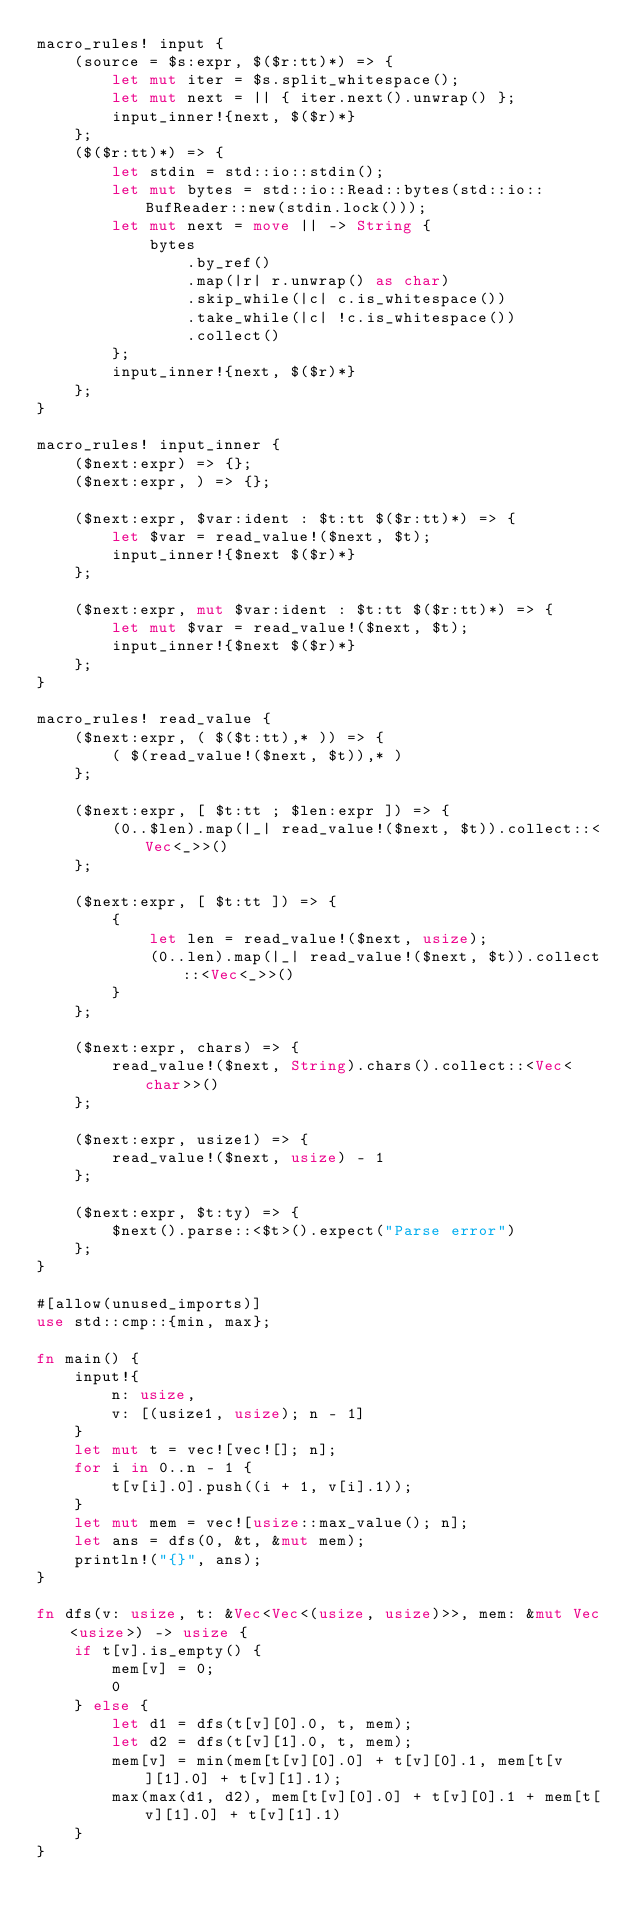<code> <loc_0><loc_0><loc_500><loc_500><_Rust_>macro_rules! input {
    (source = $s:expr, $($r:tt)*) => {
        let mut iter = $s.split_whitespace();
        let mut next = || { iter.next().unwrap() };
        input_inner!{next, $($r)*}
    };
    ($($r:tt)*) => {
        let stdin = std::io::stdin();
        let mut bytes = std::io::Read::bytes(std::io::BufReader::new(stdin.lock()));
        let mut next = move || -> String {
            bytes
                .by_ref()
                .map(|r| r.unwrap() as char)
                .skip_while(|c| c.is_whitespace())
                .take_while(|c| !c.is_whitespace())
                .collect()
        };
        input_inner!{next, $($r)*}
    };
}

macro_rules! input_inner {
    ($next:expr) => {};
    ($next:expr, ) => {};

    ($next:expr, $var:ident : $t:tt $($r:tt)*) => {
        let $var = read_value!($next, $t);
        input_inner!{$next $($r)*}
    };

    ($next:expr, mut $var:ident : $t:tt $($r:tt)*) => {
        let mut $var = read_value!($next, $t);
        input_inner!{$next $($r)*}
    };
}

macro_rules! read_value {
    ($next:expr, ( $($t:tt),* )) => {
        ( $(read_value!($next, $t)),* )
    };

    ($next:expr, [ $t:tt ; $len:expr ]) => {
        (0..$len).map(|_| read_value!($next, $t)).collect::<Vec<_>>()
    };

    ($next:expr, [ $t:tt ]) => {
        {
            let len = read_value!($next, usize);
            (0..len).map(|_| read_value!($next, $t)).collect::<Vec<_>>()
        }
    };

    ($next:expr, chars) => {
        read_value!($next, String).chars().collect::<Vec<char>>()
    };

    ($next:expr, usize1) => {
        read_value!($next, usize) - 1
    };

    ($next:expr, $t:ty) => {
        $next().parse::<$t>().expect("Parse error")
    };
}

#[allow(unused_imports)]
use std::cmp::{min, max};

fn main() {
    input!{
        n: usize,
        v: [(usize1, usize); n - 1]
    }
    let mut t = vec![vec![]; n];
    for i in 0..n - 1 {
        t[v[i].0].push((i + 1, v[i].1));
    }
    let mut mem = vec![usize::max_value(); n];
    let ans = dfs(0, &t, &mut mem);
    println!("{}", ans);
}

fn dfs(v: usize, t: &Vec<Vec<(usize, usize)>>, mem: &mut Vec<usize>) -> usize {
    if t[v].is_empty() {
        mem[v] = 0;
        0
    } else {
        let d1 = dfs(t[v][0].0, t, mem);
        let d2 = dfs(t[v][1].0, t, mem);
        mem[v] = min(mem[t[v][0].0] + t[v][0].1, mem[t[v][1].0] + t[v][1].1);
        max(max(d1, d2), mem[t[v][0].0] + t[v][0].1 + mem[t[v][1].0] + t[v][1].1)
    }
}
</code> 